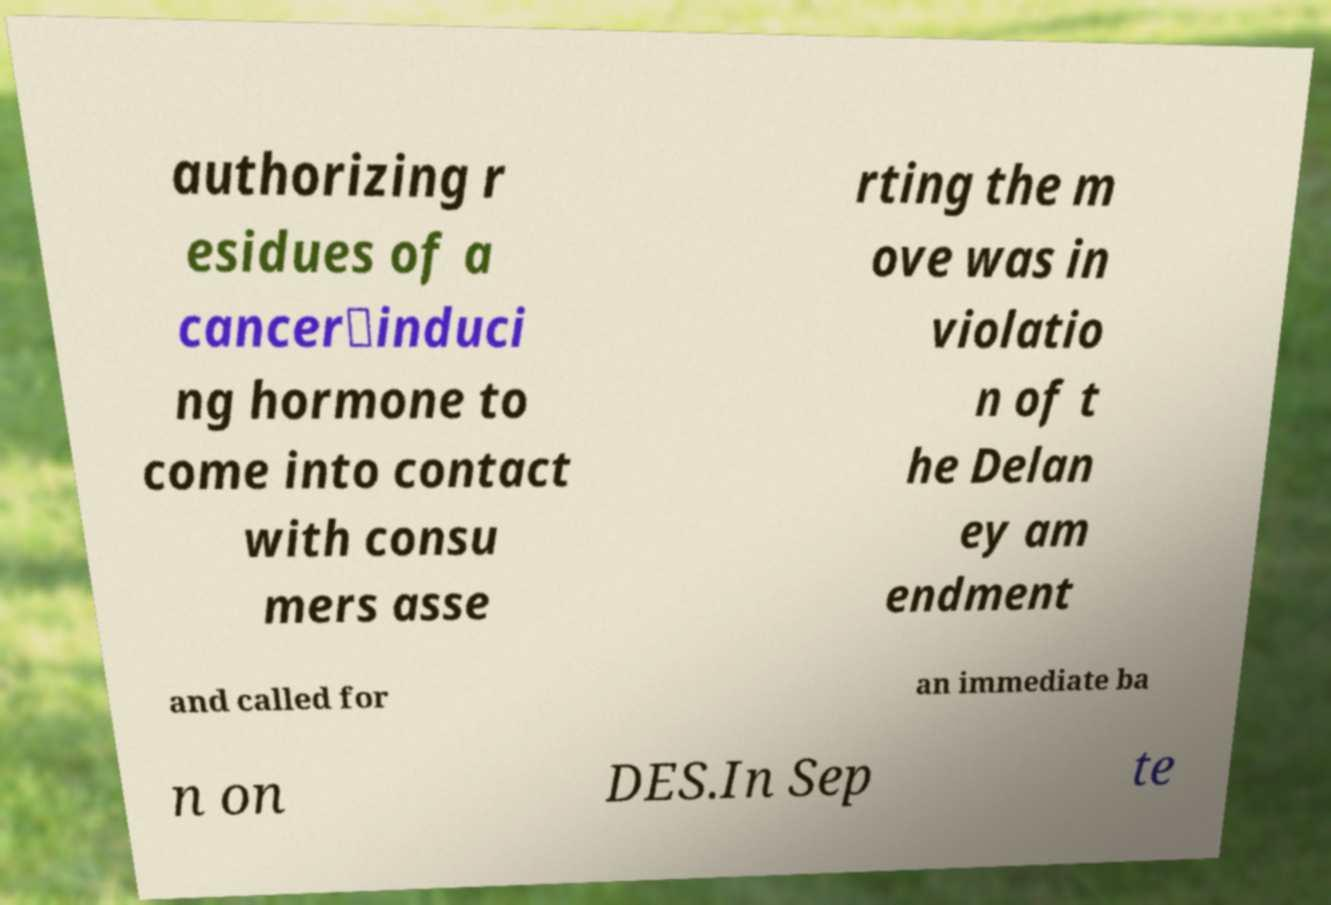Can you read and provide the text displayed in the image?This photo seems to have some interesting text. Can you extract and type it out for me? authorizing r esidues of a cancer‐induci ng hormone to come into contact with consu mers asse rting the m ove was in violatio n of t he Delan ey am endment and called for an immediate ba n on DES.In Sep te 